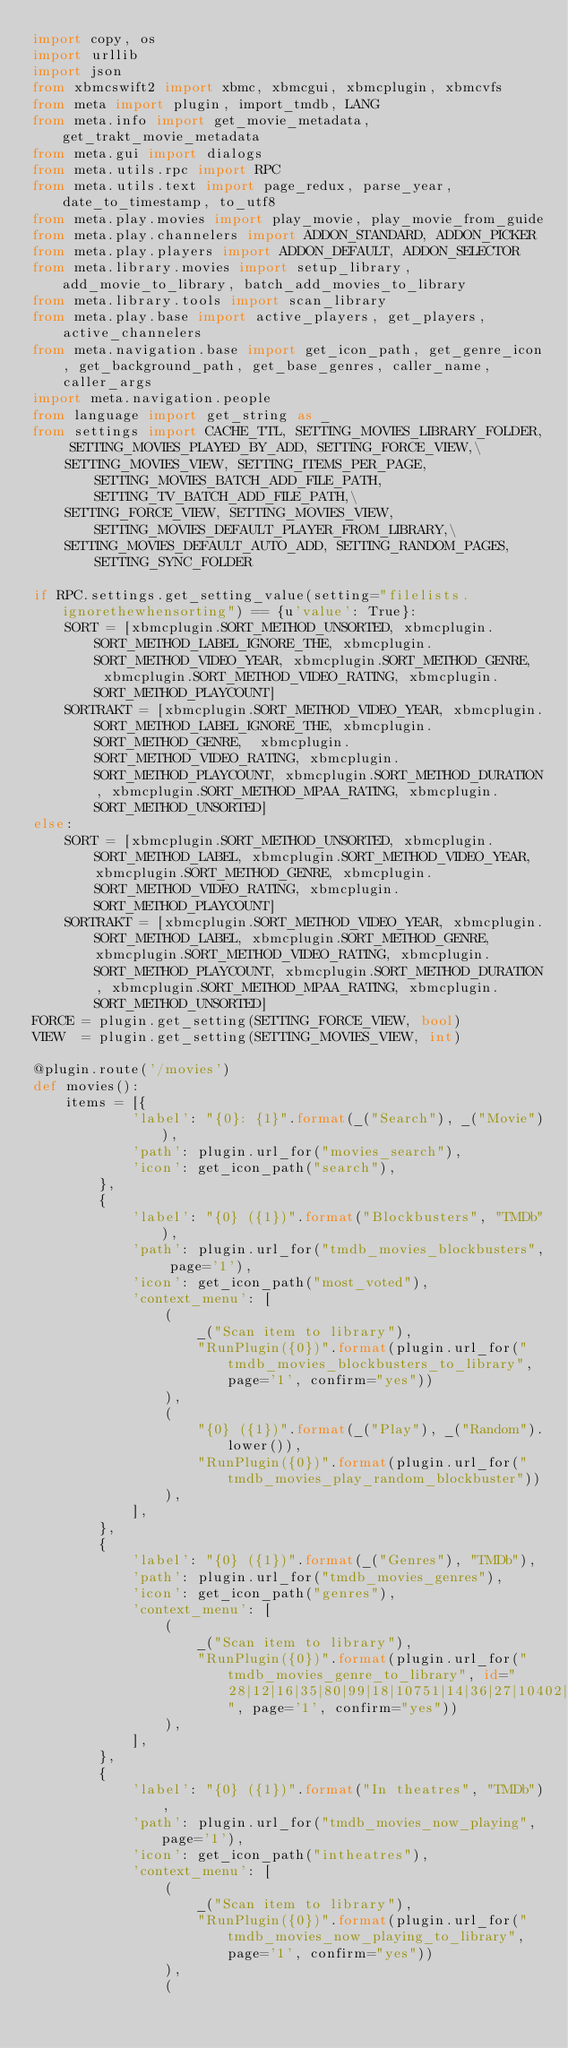<code> <loc_0><loc_0><loc_500><loc_500><_Python_>import copy, os
import urllib
import json
from xbmcswift2 import xbmc, xbmcgui, xbmcplugin, xbmcvfs
from meta import plugin, import_tmdb, LANG
from meta.info import get_movie_metadata, get_trakt_movie_metadata
from meta.gui import dialogs
from meta.utils.rpc import RPC
from meta.utils.text import page_redux, parse_year, date_to_timestamp, to_utf8
from meta.play.movies import play_movie, play_movie_from_guide
from meta.play.channelers import ADDON_STANDARD, ADDON_PICKER
from meta.play.players import ADDON_DEFAULT, ADDON_SELECTOR
from meta.library.movies import setup_library, add_movie_to_library, batch_add_movies_to_library
from meta.library.tools import scan_library
from meta.play.base import active_players, get_players, active_channelers
from meta.navigation.base import get_icon_path, get_genre_icon, get_background_path, get_base_genres, caller_name, caller_args
import meta.navigation.people
from language import get_string as _
from settings import CACHE_TTL, SETTING_MOVIES_LIBRARY_FOLDER, SETTING_MOVIES_PLAYED_BY_ADD, SETTING_FORCE_VIEW,\
    SETTING_MOVIES_VIEW, SETTING_ITEMS_PER_PAGE, SETTING_MOVIES_BATCH_ADD_FILE_PATH, SETTING_TV_BATCH_ADD_FILE_PATH,\
    SETTING_FORCE_VIEW, SETTING_MOVIES_VIEW, SETTING_MOVIES_DEFAULT_PLAYER_FROM_LIBRARY,\
    SETTING_MOVIES_DEFAULT_AUTO_ADD, SETTING_RANDOM_PAGES, SETTING_SYNC_FOLDER

if RPC.settings.get_setting_value(setting="filelists.ignorethewhensorting") == {u'value': True}:
    SORT = [xbmcplugin.SORT_METHOD_UNSORTED, xbmcplugin.SORT_METHOD_LABEL_IGNORE_THE, xbmcplugin.SORT_METHOD_VIDEO_YEAR, xbmcplugin.SORT_METHOD_GENRE,  xbmcplugin.SORT_METHOD_VIDEO_RATING, xbmcplugin.SORT_METHOD_PLAYCOUNT]
    SORTRAKT = [xbmcplugin.SORT_METHOD_VIDEO_YEAR, xbmcplugin.SORT_METHOD_LABEL_IGNORE_THE, xbmcplugin.SORT_METHOD_GENRE,  xbmcplugin.SORT_METHOD_VIDEO_RATING, xbmcplugin.SORT_METHOD_PLAYCOUNT, xbmcplugin.SORT_METHOD_DURATION, xbmcplugin.SORT_METHOD_MPAA_RATING, xbmcplugin.SORT_METHOD_UNSORTED]
else:
    SORT = [xbmcplugin.SORT_METHOD_UNSORTED, xbmcplugin.SORT_METHOD_LABEL, xbmcplugin.SORT_METHOD_VIDEO_YEAR, xbmcplugin.SORT_METHOD_GENRE, xbmcplugin.SORT_METHOD_VIDEO_RATING, xbmcplugin.SORT_METHOD_PLAYCOUNT]
    SORTRAKT = [xbmcplugin.SORT_METHOD_VIDEO_YEAR, xbmcplugin.SORT_METHOD_LABEL, xbmcplugin.SORT_METHOD_GENRE, xbmcplugin.SORT_METHOD_VIDEO_RATING, xbmcplugin.SORT_METHOD_PLAYCOUNT, xbmcplugin.SORT_METHOD_DURATION, xbmcplugin.SORT_METHOD_MPAA_RATING, xbmcplugin.SORT_METHOD_UNSORTED]
FORCE = plugin.get_setting(SETTING_FORCE_VIEW, bool)
VIEW  = plugin.get_setting(SETTING_MOVIES_VIEW, int)

@plugin.route('/movies')
def movies():
    items = [{
            'label': "{0}: {1}".format(_("Search"), _("Movie")),
            'path': plugin.url_for("movies_search"),
            'icon': get_icon_path("search"),
        },
        {
            'label': "{0} ({1})".format("Blockbusters", "TMDb"),
            'path': plugin.url_for("tmdb_movies_blockbusters", page='1'),
            'icon': get_icon_path("most_voted"),
            'context_menu': [
                (
                    _("Scan item to library"),
                    "RunPlugin({0})".format(plugin.url_for("tmdb_movies_blockbusters_to_library", page='1', confirm="yes"))
                ),
                (
                    "{0} ({1})".format(_("Play"), _("Random").lower()),
                    "RunPlugin({0})".format(plugin.url_for("tmdb_movies_play_random_blockbuster"))
                ),
            ],
        },
        {
            'label': "{0} ({1})".format(_("Genres"), "TMDb"),
            'path': plugin.url_for("tmdb_movies_genres"),
            'icon': get_icon_path("genres"),
            'context_menu': [
                (
                    _("Scan item to library"),
                    "RunPlugin({0})".format(plugin.url_for("tmdb_movies_genre_to_library", id="28|12|16|35|80|99|18|10751|14|36|27|10402|9648|10749|878|10770|53|10752|37", page='1', confirm="yes"))
                ),
            ],
        },
        {
            'label': "{0} ({1})".format("In theatres", "TMDb"),
            'path': plugin.url_for("tmdb_movies_now_playing", page='1'),
            'icon': get_icon_path("intheatres"),
            'context_menu': [
                (
                    _("Scan item to library"),
                    "RunPlugin({0})".format(plugin.url_for("tmdb_movies_now_playing_to_library", page='1', confirm="yes"))
                ),
                (</code> 